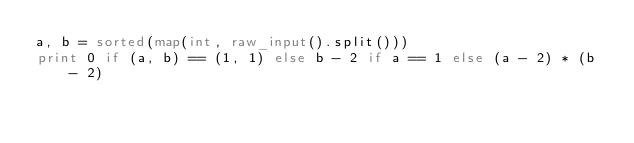Convert code to text. <code><loc_0><loc_0><loc_500><loc_500><_Python_>a, b = sorted(map(int, raw_input().split()))
print 0 if (a, b) == (1, 1) else b - 2 if a == 1 else (a - 2) * (b - 2)
</code> 